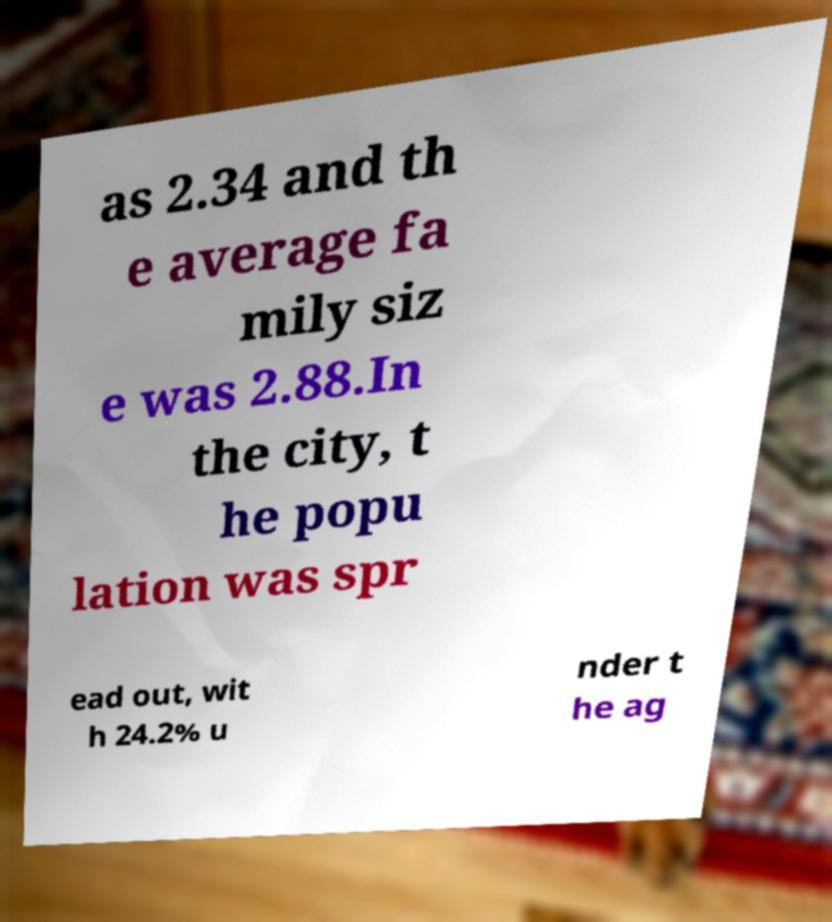There's text embedded in this image that I need extracted. Can you transcribe it verbatim? as 2.34 and th e average fa mily siz e was 2.88.In the city, t he popu lation was spr ead out, wit h 24.2% u nder t he ag 